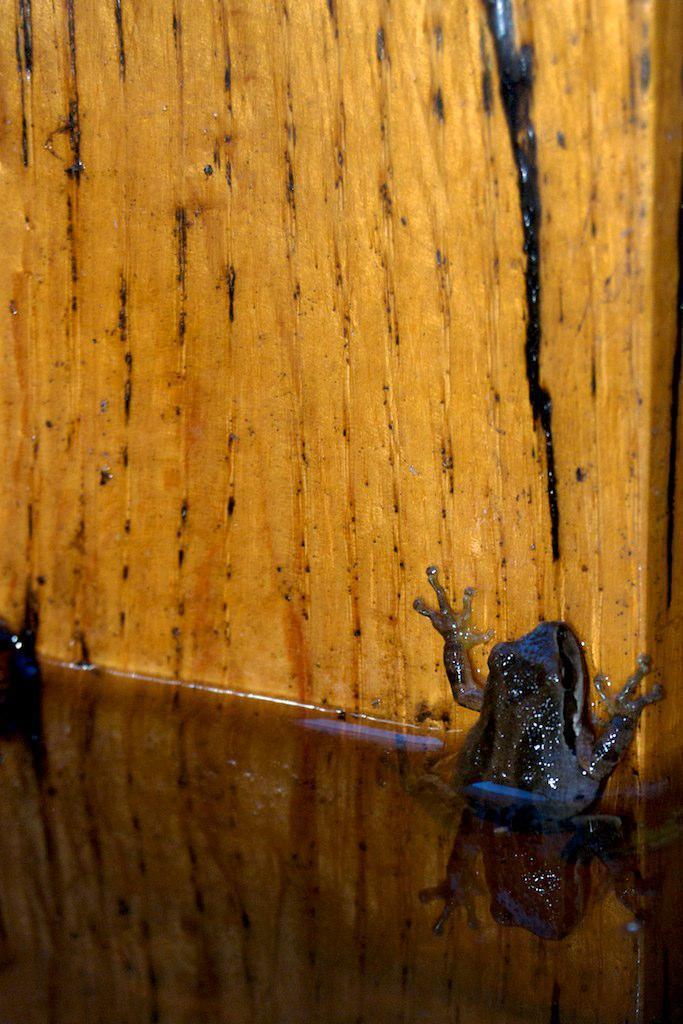Could you give a brief overview of what you see in this image? In this image there is a wooden board. On the right side of the image there is a frog on the wooden board. 